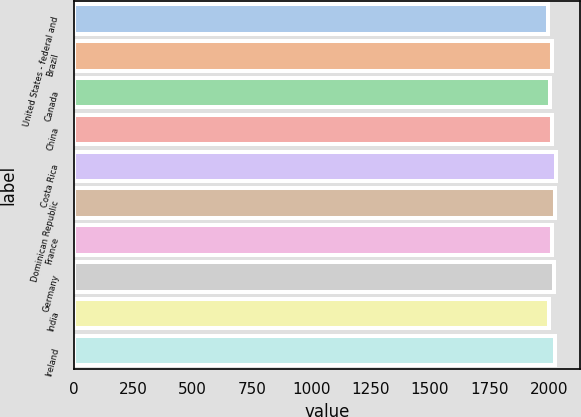Convert chart to OTSL. <chart><loc_0><loc_0><loc_500><loc_500><bar_chart><fcel>United States - federal and<fcel>Brazil<fcel>Canada<fcel>China<fcel>Costa Rica<fcel>Dominican Republic<fcel>France<fcel>Germany<fcel>India<fcel>Ireland<nl><fcel>1996<fcel>2013.6<fcel>2005.6<fcel>2015.2<fcel>2029.6<fcel>2028<fcel>2012<fcel>2023.2<fcel>2002<fcel>2024.8<nl></chart> 